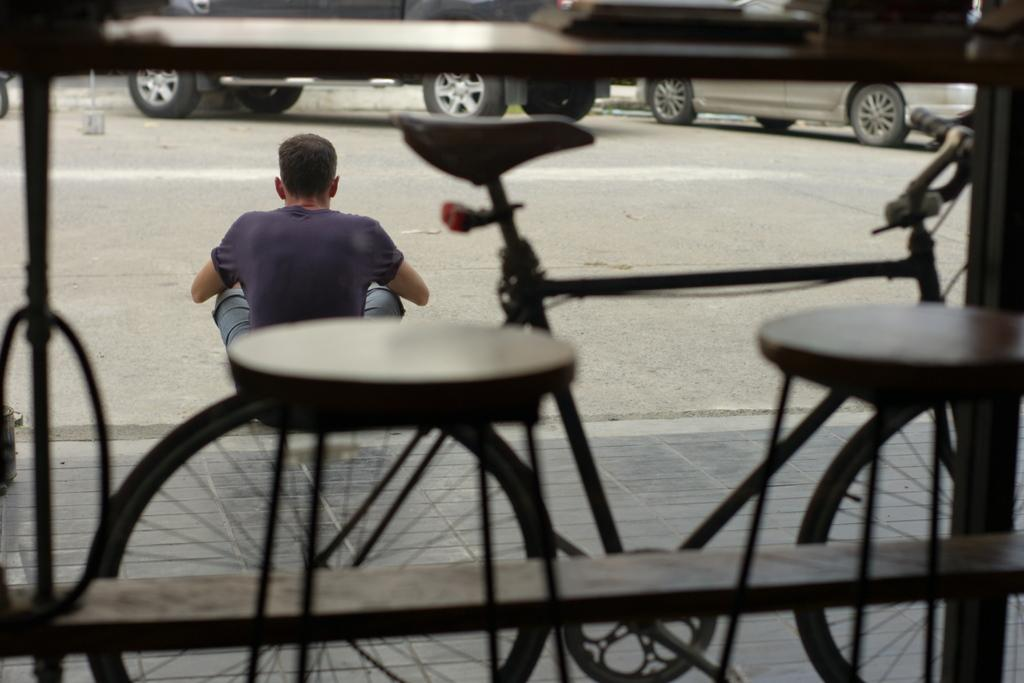Who is present in the image? There is a man in the image. What is the man doing in the image? The man is sitting on the road. What is in front of the man? There is a car in front of the man. What can be seen in the background of the image? A cycle is visible in the background of the image. How is the man visible in relation to the cycle? The man is visible through the cycle. What type of scale can be seen in the image? There is no scale present in the image. Is the man crying in the image? The image does not show the man crying or displaying any emotions. What is the man doing with the banana in the image? There is no banana present in the image. 